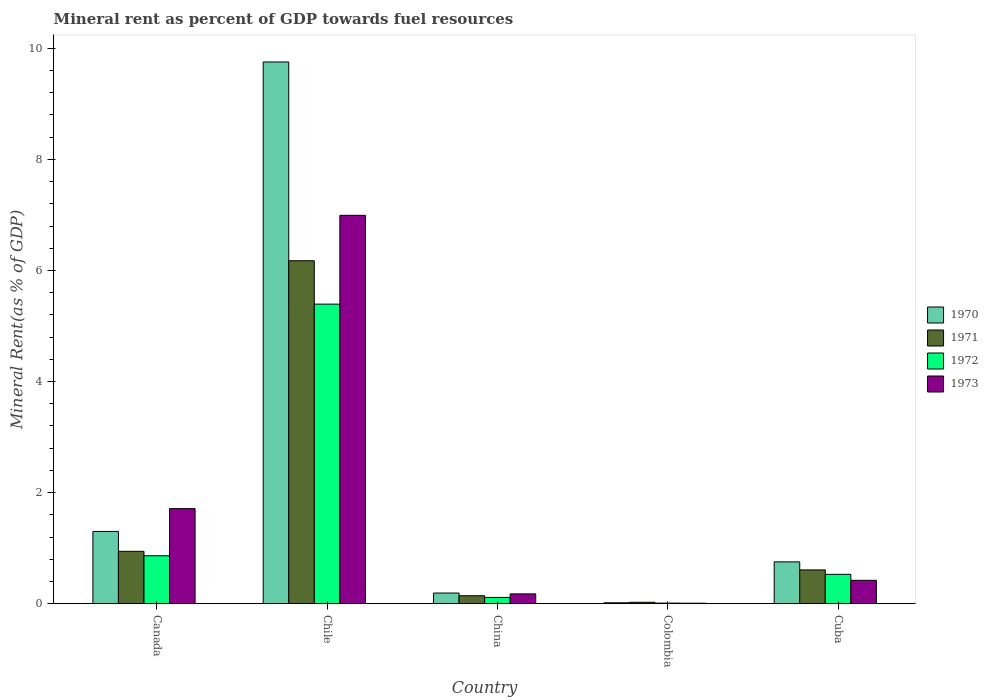How many different coloured bars are there?
Keep it short and to the point. 4. How many groups of bars are there?
Offer a very short reply. 5. Are the number of bars per tick equal to the number of legend labels?
Your response must be concise. Yes. Are the number of bars on each tick of the X-axis equal?
Give a very brief answer. Yes. How many bars are there on the 4th tick from the left?
Keep it short and to the point. 4. What is the label of the 5th group of bars from the left?
Your response must be concise. Cuba. What is the mineral rent in 1973 in China?
Make the answer very short. 0.18. Across all countries, what is the maximum mineral rent in 1973?
Your answer should be compact. 6.99. Across all countries, what is the minimum mineral rent in 1971?
Provide a succinct answer. 0.03. In which country was the mineral rent in 1972 maximum?
Your answer should be compact. Chile. What is the total mineral rent in 1970 in the graph?
Offer a terse response. 12.02. What is the difference between the mineral rent in 1972 in Canada and that in Cuba?
Your answer should be compact. 0.33. What is the difference between the mineral rent in 1970 in Chile and the mineral rent in 1973 in Cuba?
Your response must be concise. 9.33. What is the average mineral rent in 1973 per country?
Keep it short and to the point. 1.86. What is the difference between the mineral rent of/in 1970 and mineral rent of/in 1971 in China?
Offer a terse response. 0.05. In how many countries, is the mineral rent in 1973 greater than 5.6 %?
Provide a succinct answer. 1. What is the ratio of the mineral rent in 1973 in Chile to that in China?
Provide a short and direct response. 39.41. Is the mineral rent in 1971 in Canada less than that in China?
Provide a succinct answer. No. Is the difference between the mineral rent in 1970 in Chile and China greater than the difference between the mineral rent in 1971 in Chile and China?
Provide a succinct answer. Yes. What is the difference between the highest and the second highest mineral rent in 1972?
Provide a succinct answer. 0.33. What is the difference between the highest and the lowest mineral rent in 1971?
Provide a succinct answer. 6.15. In how many countries, is the mineral rent in 1972 greater than the average mineral rent in 1972 taken over all countries?
Offer a terse response. 1. Is the sum of the mineral rent in 1970 in Colombia and Cuba greater than the maximum mineral rent in 1973 across all countries?
Provide a succinct answer. No. Is it the case that in every country, the sum of the mineral rent in 1972 and mineral rent in 1970 is greater than the sum of mineral rent in 1971 and mineral rent in 1973?
Provide a succinct answer. No. What does the 3rd bar from the right in Colombia represents?
Your response must be concise. 1971. Is it the case that in every country, the sum of the mineral rent in 1973 and mineral rent in 1971 is greater than the mineral rent in 1972?
Your response must be concise. Yes. Are all the bars in the graph horizontal?
Give a very brief answer. No. How many countries are there in the graph?
Provide a short and direct response. 5. What is the difference between two consecutive major ticks on the Y-axis?
Provide a short and direct response. 2. Are the values on the major ticks of Y-axis written in scientific E-notation?
Offer a very short reply. No. Does the graph contain any zero values?
Make the answer very short. No. Does the graph contain grids?
Your response must be concise. No. Where does the legend appear in the graph?
Make the answer very short. Center right. How many legend labels are there?
Offer a terse response. 4. What is the title of the graph?
Offer a terse response. Mineral rent as percent of GDP towards fuel resources. Does "1965" appear as one of the legend labels in the graph?
Your answer should be compact. No. What is the label or title of the Y-axis?
Give a very brief answer. Mineral Rent(as % of GDP). What is the Mineral Rent(as % of GDP) in 1970 in Canada?
Ensure brevity in your answer.  1.3. What is the Mineral Rent(as % of GDP) in 1971 in Canada?
Offer a terse response. 0.94. What is the Mineral Rent(as % of GDP) of 1972 in Canada?
Provide a succinct answer. 0.86. What is the Mineral Rent(as % of GDP) in 1973 in Canada?
Your response must be concise. 1.71. What is the Mineral Rent(as % of GDP) of 1970 in Chile?
Provide a short and direct response. 9.75. What is the Mineral Rent(as % of GDP) of 1971 in Chile?
Keep it short and to the point. 6.18. What is the Mineral Rent(as % of GDP) in 1972 in Chile?
Give a very brief answer. 5.39. What is the Mineral Rent(as % of GDP) in 1973 in Chile?
Give a very brief answer. 6.99. What is the Mineral Rent(as % of GDP) in 1970 in China?
Your response must be concise. 0.19. What is the Mineral Rent(as % of GDP) of 1971 in China?
Give a very brief answer. 0.14. What is the Mineral Rent(as % of GDP) in 1972 in China?
Your response must be concise. 0.11. What is the Mineral Rent(as % of GDP) of 1973 in China?
Give a very brief answer. 0.18. What is the Mineral Rent(as % of GDP) of 1970 in Colombia?
Your answer should be compact. 0.02. What is the Mineral Rent(as % of GDP) of 1971 in Colombia?
Offer a terse response. 0.03. What is the Mineral Rent(as % of GDP) of 1972 in Colombia?
Provide a short and direct response. 0.01. What is the Mineral Rent(as % of GDP) of 1973 in Colombia?
Your answer should be compact. 0.01. What is the Mineral Rent(as % of GDP) of 1970 in Cuba?
Provide a short and direct response. 0.75. What is the Mineral Rent(as % of GDP) in 1971 in Cuba?
Ensure brevity in your answer.  0.61. What is the Mineral Rent(as % of GDP) of 1972 in Cuba?
Offer a terse response. 0.53. What is the Mineral Rent(as % of GDP) of 1973 in Cuba?
Make the answer very short. 0.42. Across all countries, what is the maximum Mineral Rent(as % of GDP) of 1970?
Provide a succinct answer. 9.75. Across all countries, what is the maximum Mineral Rent(as % of GDP) of 1971?
Offer a very short reply. 6.18. Across all countries, what is the maximum Mineral Rent(as % of GDP) of 1972?
Ensure brevity in your answer.  5.39. Across all countries, what is the maximum Mineral Rent(as % of GDP) of 1973?
Your answer should be very brief. 6.99. Across all countries, what is the minimum Mineral Rent(as % of GDP) in 1970?
Provide a succinct answer. 0.02. Across all countries, what is the minimum Mineral Rent(as % of GDP) in 1971?
Ensure brevity in your answer.  0.03. Across all countries, what is the minimum Mineral Rent(as % of GDP) of 1972?
Provide a succinct answer. 0.01. Across all countries, what is the minimum Mineral Rent(as % of GDP) in 1973?
Offer a terse response. 0.01. What is the total Mineral Rent(as % of GDP) of 1970 in the graph?
Keep it short and to the point. 12.02. What is the total Mineral Rent(as % of GDP) in 1971 in the graph?
Provide a short and direct response. 7.9. What is the total Mineral Rent(as % of GDP) in 1972 in the graph?
Make the answer very short. 6.91. What is the total Mineral Rent(as % of GDP) in 1973 in the graph?
Your answer should be compact. 9.31. What is the difference between the Mineral Rent(as % of GDP) of 1970 in Canada and that in Chile?
Offer a terse response. -8.45. What is the difference between the Mineral Rent(as % of GDP) in 1971 in Canada and that in Chile?
Your answer should be compact. -5.23. What is the difference between the Mineral Rent(as % of GDP) in 1972 in Canada and that in Chile?
Ensure brevity in your answer.  -4.53. What is the difference between the Mineral Rent(as % of GDP) of 1973 in Canada and that in Chile?
Give a very brief answer. -5.28. What is the difference between the Mineral Rent(as % of GDP) of 1970 in Canada and that in China?
Ensure brevity in your answer.  1.11. What is the difference between the Mineral Rent(as % of GDP) in 1971 in Canada and that in China?
Your response must be concise. 0.8. What is the difference between the Mineral Rent(as % of GDP) in 1972 in Canada and that in China?
Your answer should be very brief. 0.75. What is the difference between the Mineral Rent(as % of GDP) of 1973 in Canada and that in China?
Offer a very short reply. 1.53. What is the difference between the Mineral Rent(as % of GDP) of 1970 in Canada and that in Colombia?
Give a very brief answer. 1.28. What is the difference between the Mineral Rent(as % of GDP) in 1971 in Canada and that in Colombia?
Offer a terse response. 0.92. What is the difference between the Mineral Rent(as % of GDP) of 1972 in Canada and that in Colombia?
Give a very brief answer. 0.85. What is the difference between the Mineral Rent(as % of GDP) of 1973 in Canada and that in Colombia?
Your answer should be compact. 1.7. What is the difference between the Mineral Rent(as % of GDP) in 1970 in Canada and that in Cuba?
Make the answer very short. 0.55. What is the difference between the Mineral Rent(as % of GDP) in 1971 in Canada and that in Cuba?
Keep it short and to the point. 0.33. What is the difference between the Mineral Rent(as % of GDP) in 1972 in Canada and that in Cuba?
Your response must be concise. 0.33. What is the difference between the Mineral Rent(as % of GDP) in 1973 in Canada and that in Cuba?
Your response must be concise. 1.29. What is the difference between the Mineral Rent(as % of GDP) in 1970 in Chile and that in China?
Your response must be concise. 9.56. What is the difference between the Mineral Rent(as % of GDP) of 1971 in Chile and that in China?
Provide a succinct answer. 6.03. What is the difference between the Mineral Rent(as % of GDP) in 1972 in Chile and that in China?
Your answer should be compact. 5.28. What is the difference between the Mineral Rent(as % of GDP) of 1973 in Chile and that in China?
Offer a very short reply. 6.82. What is the difference between the Mineral Rent(as % of GDP) of 1970 in Chile and that in Colombia?
Provide a short and direct response. 9.74. What is the difference between the Mineral Rent(as % of GDP) in 1971 in Chile and that in Colombia?
Your answer should be compact. 6.15. What is the difference between the Mineral Rent(as % of GDP) in 1972 in Chile and that in Colombia?
Provide a short and direct response. 5.38. What is the difference between the Mineral Rent(as % of GDP) in 1973 in Chile and that in Colombia?
Provide a succinct answer. 6.98. What is the difference between the Mineral Rent(as % of GDP) in 1970 in Chile and that in Cuba?
Your answer should be very brief. 9. What is the difference between the Mineral Rent(as % of GDP) of 1971 in Chile and that in Cuba?
Provide a succinct answer. 5.57. What is the difference between the Mineral Rent(as % of GDP) in 1972 in Chile and that in Cuba?
Your response must be concise. 4.86. What is the difference between the Mineral Rent(as % of GDP) of 1973 in Chile and that in Cuba?
Keep it short and to the point. 6.57. What is the difference between the Mineral Rent(as % of GDP) of 1970 in China and that in Colombia?
Your answer should be very brief. 0.18. What is the difference between the Mineral Rent(as % of GDP) of 1971 in China and that in Colombia?
Your response must be concise. 0.12. What is the difference between the Mineral Rent(as % of GDP) in 1972 in China and that in Colombia?
Offer a terse response. 0.1. What is the difference between the Mineral Rent(as % of GDP) in 1973 in China and that in Colombia?
Offer a terse response. 0.17. What is the difference between the Mineral Rent(as % of GDP) of 1970 in China and that in Cuba?
Give a very brief answer. -0.56. What is the difference between the Mineral Rent(as % of GDP) in 1971 in China and that in Cuba?
Your response must be concise. -0.46. What is the difference between the Mineral Rent(as % of GDP) in 1972 in China and that in Cuba?
Give a very brief answer. -0.42. What is the difference between the Mineral Rent(as % of GDP) of 1973 in China and that in Cuba?
Provide a succinct answer. -0.24. What is the difference between the Mineral Rent(as % of GDP) in 1970 in Colombia and that in Cuba?
Keep it short and to the point. -0.74. What is the difference between the Mineral Rent(as % of GDP) in 1971 in Colombia and that in Cuba?
Provide a short and direct response. -0.58. What is the difference between the Mineral Rent(as % of GDP) of 1972 in Colombia and that in Cuba?
Keep it short and to the point. -0.52. What is the difference between the Mineral Rent(as % of GDP) of 1973 in Colombia and that in Cuba?
Give a very brief answer. -0.41. What is the difference between the Mineral Rent(as % of GDP) of 1970 in Canada and the Mineral Rent(as % of GDP) of 1971 in Chile?
Offer a terse response. -4.87. What is the difference between the Mineral Rent(as % of GDP) of 1970 in Canada and the Mineral Rent(as % of GDP) of 1972 in Chile?
Offer a terse response. -4.09. What is the difference between the Mineral Rent(as % of GDP) of 1970 in Canada and the Mineral Rent(as % of GDP) of 1973 in Chile?
Provide a succinct answer. -5.69. What is the difference between the Mineral Rent(as % of GDP) in 1971 in Canada and the Mineral Rent(as % of GDP) in 1972 in Chile?
Your answer should be very brief. -4.45. What is the difference between the Mineral Rent(as % of GDP) of 1971 in Canada and the Mineral Rent(as % of GDP) of 1973 in Chile?
Give a very brief answer. -6.05. What is the difference between the Mineral Rent(as % of GDP) in 1972 in Canada and the Mineral Rent(as % of GDP) in 1973 in Chile?
Offer a terse response. -6.13. What is the difference between the Mineral Rent(as % of GDP) of 1970 in Canada and the Mineral Rent(as % of GDP) of 1971 in China?
Provide a short and direct response. 1.16. What is the difference between the Mineral Rent(as % of GDP) of 1970 in Canada and the Mineral Rent(as % of GDP) of 1972 in China?
Provide a short and direct response. 1.19. What is the difference between the Mineral Rent(as % of GDP) of 1970 in Canada and the Mineral Rent(as % of GDP) of 1973 in China?
Offer a very short reply. 1.12. What is the difference between the Mineral Rent(as % of GDP) in 1971 in Canada and the Mineral Rent(as % of GDP) in 1972 in China?
Give a very brief answer. 0.83. What is the difference between the Mineral Rent(as % of GDP) in 1971 in Canada and the Mineral Rent(as % of GDP) in 1973 in China?
Ensure brevity in your answer.  0.77. What is the difference between the Mineral Rent(as % of GDP) in 1972 in Canada and the Mineral Rent(as % of GDP) in 1973 in China?
Provide a succinct answer. 0.69. What is the difference between the Mineral Rent(as % of GDP) of 1970 in Canada and the Mineral Rent(as % of GDP) of 1971 in Colombia?
Give a very brief answer. 1.28. What is the difference between the Mineral Rent(as % of GDP) in 1970 in Canada and the Mineral Rent(as % of GDP) in 1972 in Colombia?
Make the answer very short. 1.29. What is the difference between the Mineral Rent(as % of GDP) of 1970 in Canada and the Mineral Rent(as % of GDP) of 1973 in Colombia?
Keep it short and to the point. 1.29. What is the difference between the Mineral Rent(as % of GDP) of 1971 in Canada and the Mineral Rent(as % of GDP) of 1972 in Colombia?
Provide a succinct answer. 0.93. What is the difference between the Mineral Rent(as % of GDP) of 1971 in Canada and the Mineral Rent(as % of GDP) of 1973 in Colombia?
Provide a short and direct response. 0.93. What is the difference between the Mineral Rent(as % of GDP) in 1972 in Canada and the Mineral Rent(as % of GDP) in 1973 in Colombia?
Provide a succinct answer. 0.85. What is the difference between the Mineral Rent(as % of GDP) of 1970 in Canada and the Mineral Rent(as % of GDP) of 1971 in Cuba?
Make the answer very short. 0.69. What is the difference between the Mineral Rent(as % of GDP) of 1970 in Canada and the Mineral Rent(as % of GDP) of 1972 in Cuba?
Ensure brevity in your answer.  0.77. What is the difference between the Mineral Rent(as % of GDP) of 1970 in Canada and the Mineral Rent(as % of GDP) of 1973 in Cuba?
Your response must be concise. 0.88. What is the difference between the Mineral Rent(as % of GDP) in 1971 in Canada and the Mineral Rent(as % of GDP) in 1972 in Cuba?
Your answer should be compact. 0.41. What is the difference between the Mineral Rent(as % of GDP) of 1971 in Canada and the Mineral Rent(as % of GDP) of 1973 in Cuba?
Your answer should be very brief. 0.52. What is the difference between the Mineral Rent(as % of GDP) in 1972 in Canada and the Mineral Rent(as % of GDP) in 1973 in Cuba?
Your answer should be very brief. 0.44. What is the difference between the Mineral Rent(as % of GDP) in 1970 in Chile and the Mineral Rent(as % of GDP) in 1971 in China?
Provide a succinct answer. 9.61. What is the difference between the Mineral Rent(as % of GDP) of 1970 in Chile and the Mineral Rent(as % of GDP) of 1972 in China?
Your answer should be very brief. 9.64. What is the difference between the Mineral Rent(as % of GDP) of 1970 in Chile and the Mineral Rent(as % of GDP) of 1973 in China?
Make the answer very short. 9.58. What is the difference between the Mineral Rent(as % of GDP) in 1971 in Chile and the Mineral Rent(as % of GDP) in 1972 in China?
Give a very brief answer. 6.06. What is the difference between the Mineral Rent(as % of GDP) of 1971 in Chile and the Mineral Rent(as % of GDP) of 1973 in China?
Offer a terse response. 6. What is the difference between the Mineral Rent(as % of GDP) of 1972 in Chile and the Mineral Rent(as % of GDP) of 1973 in China?
Your answer should be very brief. 5.22. What is the difference between the Mineral Rent(as % of GDP) of 1970 in Chile and the Mineral Rent(as % of GDP) of 1971 in Colombia?
Provide a succinct answer. 9.73. What is the difference between the Mineral Rent(as % of GDP) in 1970 in Chile and the Mineral Rent(as % of GDP) in 1972 in Colombia?
Provide a succinct answer. 9.74. What is the difference between the Mineral Rent(as % of GDP) in 1970 in Chile and the Mineral Rent(as % of GDP) in 1973 in Colombia?
Your answer should be very brief. 9.74. What is the difference between the Mineral Rent(as % of GDP) in 1971 in Chile and the Mineral Rent(as % of GDP) in 1972 in Colombia?
Your answer should be very brief. 6.16. What is the difference between the Mineral Rent(as % of GDP) of 1971 in Chile and the Mineral Rent(as % of GDP) of 1973 in Colombia?
Your response must be concise. 6.17. What is the difference between the Mineral Rent(as % of GDP) in 1972 in Chile and the Mineral Rent(as % of GDP) in 1973 in Colombia?
Your answer should be very brief. 5.38. What is the difference between the Mineral Rent(as % of GDP) in 1970 in Chile and the Mineral Rent(as % of GDP) in 1971 in Cuba?
Give a very brief answer. 9.15. What is the difference between the Mineral Rent(as % of GDP) of 1970 in Chile and the Mineral Rent(as % of GDP) of 1972 in Cuba?
Give a very brief answer. 9.22. What is the difference between the Mineral Rent(as % of GDP) of 1970 in Chile and the Mineral Rent(as % of GDP) of 1973 in Cuba?
Offer a terse response. 9.33. What is the difference between the Mineral Rent(as % of GDP) in 1971 in Chile and the Mineral Rent(as % of GDP) in 1972 in Cuba?
Ensure brevity in your answer.  5.65. What is the difference between the Mineral Rent(as % of GDP) of 1971 in Chile and the Mineral Rent(as % of GDP) of 1973 in Cuba?
Ensure brevity in your answer.  5.75. What is the difference between the Mineral Rent(as % of GDP) in 1972 in Chile and the Mineral Rent(as % of GDP) in 1973 in Cuba?
Keep it short and to the point. 4.97. What is the difference between the Mineral Rent(as % of GDP) in 1970 in China and the Mineral Rent(as % of GDP) in 1971 in Colombia?
Give a very brief answer. 0.17. What is the difference between the Mineral Rent(as % of GDP) in 1970 in China and the Mineral Rent(as % of GDP) in 1972 in Colombia?
Your answer should be compact. 0.18. What is the difference between the Mineral Rent(as % of GDP) of 1970 in China and the Mineral Rent(as % of GDP) of 1973 in Colombia?
Your answer should be compact. 0.18. What is the difference between the Mineral Rent(as % of GDP) in 1971 in China and the Mineral Rent(as % of GDP) in 1972 in Colombia?
Provide a short and direct response. 0.13. What is the difference between the Mineral Rent(as % of GDP) of 1971 in China and the Mineral Rent(as % of GDP) of 1973 in Colombia?
Your answer should be compact. 0.13. What is the difference between the Mineral Rent(as % of GDP) of 1972 in China and the Mineral Rent(as % of GDP) of 1973 in Colombia?
Keep it short and to the point. 0.1. What is the difference between the Mineral Rent(as % of GDP) in 1970 in China and the Mineral Rent(as % of GDP) in 1971 in Cuba?
Provide a succinct answer. -0.42. What is the difference between the Mineral Rent(as % of GDP) in 1970 in China and the Mineral Rent(as % of GDP) in 1972 in Cuba?
Your answer should be compact. -0.34. What is the difference between the Mineral Rent(as % of GDP) in 1970 in China and the Mineral Rent(as % of GDP) in 1973 in Cuba?
Ensure brevity in your answer.  -0.23. What is the difference between the Mineral Rent(as % of GDP) of 1971 in China and the Mineral Rent(as % of GDP) of 1972 in Cuba?
Make the answer very short. -0.39. What is the difference between the Mineral Rent(as % of GDP) of 1971 in China and the Mineral Rent(as % of GDP) of 1973 in Cuba?
Keep it short and to the point. -0.28. What is the difference between the Mineral Rent(as % of GDP) in 1972 in China and the Mineral Rent(as % of GDP) in 1973 in Cuba?
Provide a succinct answer. -0.31. What is the difference between the Mineral Rent(as % of GDP) in 1970 in Colombia and the Mineral Rent(as % of GDP) in 1971 in Cuba?
Ensure brevity in your answer.  -0.59. What is the difference between the Mineral Rent(as % of GDP) of 1970 in Colombia and the Mineral Rent(as % of GDP) of 1972 in Cuba?
Keep it short and to the point. -0.51. What is the difference between the Mineral Rent(as % of GDP) of 1970 in Colombia and the Mineral Rent(as % of GDP) of 1973 in Cuba?
Your response must be concise. -0.4. What is the difference between the Mineral Rent(as % of GDP) of 1971 in Colombia and the Mineral Rent(as % of GDP) of 1972 in Cuba?
Make the answer very short. -0.5. What is the difference between the Mineral Rent(as % of GDP) in 1971 in Colombia and the Mineral Rent(as % of GDP) in 1973 in Cuba?
Give a very brief answer. -0.4. What is the difference between the Mineral Rent(as % of GDP) in 1972 in Colombia and the Mineral Rent(as % of GDP) in 1973 in Cuba?
Keep it short and to the point. -0.41. What is the average Mineral Rent(as % of GDP) of 1970 per country?
Provide a short and direct response. 2.4. What is the average Mineral Rent(as % of GDP) in 1971 per country?
Give a very brief answer. 1.58. What is the average Mineral Rent(as % of GDP) of 1972 per country?
Offer a terse response. 1.38. What is the average Mineral Rent(as % of GDP) of 1973 per country?
Your answer should be very brief. 1.86. What is the difference between the Mineral Rent(as % of GDP) in 1970 and Mineral Rent(as % of GDP) in 1971 in Canada?
Give a very brief answer. 0.36. What is the difference between the Mineral Rent(as % of GDP) in 1970 and Mineral Rent(as % of GDP) in 1972 in Canada?
Offer a terse response. 0.44. What is the difference between the Mineral Rent(as % of GDP) of 1970 and Mineral Rent(as % of GDP) of 1973 in Canada?
Ensure brevity in your answer.  -0.41. What is the difference between the Mineral Rent(as % of GDP) of 1971 and Mineral Rent(as % of GDP) of 1972 in Canada?
Make the answer very short. 0.08. What is the difference between the Mineral Rent(as % of GDP) in 1971 and Mineral Rent(as % of GDP) in 1973 in Canada?
Offer a terse response. -0.77. What is the difference between the Mineral Rent(as % of GDP) of 1972 and Mineral Rent(as % of GDP) of 1973 in Canada?
Make the answer very short. -0.85. What is the difference between the Mineral Rent(as % of GDP) in 1970 and Mineral Rent(as % of GDP) in 1971 in Chile?
Provide a short and direct response. 3.58. What is the difference between the Mineral Rent(as % of GDP) in 1970 and Mineral Rent(as % of GDP) in 1972 in Chile?
Your answer should be very brief. 4.36. What is the difference between the Mineral Rent(as % of GDP) of 1970 and Mineral Rent(as % of GDP) of 1973 in Chile?
Provide a short and direct response. 2.76. What is the difference between the Mineral Rent(as % of GDP) in 1971 and Mineral Rent(as % of GDP) in 1972 in Chile?
Keep it short and to the point. 0.78. What is the difference between the Mineral Rent(as % of GDP) of 1971 and Mineral Rent(as % of GDP) of 1973 in Chile?
Keep it short and to the point. -0.82. What is the difference between the Mineral Rent(as % of GDP) of 1972 and Mineral Rent(as % of GDP) of 1973 in Chile?
Your answer should be compact. -1.6. What is the difference between the Mineral Rent(as % of GDP) in 1970 and Mineral Rent(as % of GDP) in 1971 in China?
Provide a succinct answer. 0.05. What is the difference between the Mineral Rent(as % of GDP) of 1970 and Mineral Rent(as % of GDP) of 1972 in China?
Provide a succinct answer. 0.08. What is the difference between the Mineral Rent(as % of GDP) of 1970 and Mineral Rent(as % of GDP) of 1973 in China?
Offer a terse response. 0.02. What is the difference between the Mineral Rent(as % of GDP) in 1971 and Mineral Rent(as % of GDP) in 1972 in China?
Provide a short and direct response. 0.03. What is the difference between the Mineral Rent(as % of GDP) of 1971 and Mineral Rent(as % of GDP) of 1973 in China?
Give a very brief answer. -0.03. What is the difference between the Mineral Rent(as % of GDP) of 1972 and Mineral Rent(as % of GDP) of 1973 in China?
Your answer should be very brief. -0.06. What is the difference between the Mineral Rent(as % of GDP) in 1970 and Mineral Rent(as % of GDP) in 1971 in Colombia?
Make the answer very short. -0.01. What is the difference between the Mineral Rent(as % of GDP) in 1970 and Mineral Rent(as % of GDP) in 1972 in Colombia?
Provide a succinct answer. 0.01. What is the difference between the Mineral Rent(as % of GDP) of 1970 and Mineral Rent(as % of GDP) of 1973 in Colombia?
Your answer should be compact. 0.01. What is the difference between the Mineral Rent(as % of GDP) of 1971 and Mineral Rent(as % of GDP) of 1972 in Colombia?
Keep it short and to the point. 0.01. What is the difference between the Mineral Rent(as % of GDP) in 1971 and Mineral Rent(as % of GDP) in 1973 in Colombia?
Offer a terse response. 0.02. What is the difference between the Mineral Rent(as % of GDP) in 1972 and Mineral Rent(as % of GDP) in 1973 in Colombia?
Provide a short and direct response. 0. What is the difference between the Mineral Rent(as % of GDP) of 1970 and Mineral Rent(as % of GDP) of 1971 in Cuba?
Provide a succinct answer. 0.14. What is the difference between the Mineral Rent(as % of GDP) in 1970 and Mineral Rent(as % of GDP) in 1972 in Cuba?
Offer a terse response. 0.22. What is the difference between the Mineral Rent(as % of GDP) in 1970 and Mineral Rent(as % of GDP) in 1973 in Cuba?
Keep it short and to the point. 0.33. What is the difference between the Mineral Rent(as % of GDP) in 1971 and Mineral Rent(as % of GDP) in 1972 in Cuba?
Keep it short and to the point. 0.08. What is the difference between the Mineral Rent(as % of GDP) in 1971 and Mineral Rent(as % of GDP) in 1973 in Cuba?
Provide a short and direct response. 0.19. What is the difference between the Mineral Rent(as % of GDP) in 1972 and Mineral Rent(as % of GDP) in 1973 in Cuba?
Keep it short and to the point. 0.11. What is the ratio of the Mineral Rent(as % of GDP) in 1970 in Canada to that in Chile?
Make the answer very short. 0.13. What is the ratio of the Mineral Rent(as % of GDP) of 1971 in Canada to that in Chile?
Your response must be concise. 0.15. What is the ratio of the Mineral Rent(as % of GDP) in 1972 in Canada to that in Chile?
Your answer should be compact. 0.16. What is the ratio of the Mineral Rent(as % of GDP) in 1973 in Canada to that in Chile?
Provide a short and direct response. 0.24. What is the ratio of the Mineral Rent(as % of GDP) in 1970 in Canada to that in China?
Provide a succinct answer. 6.76. What is the ratio of the Mineral Rent(as % of GDP) of 1971 in Canada to that in China?
Provide a short and direct response. 6.54. What is the ratio of the Mineral Rent(as % of GDP) in 1972 in Canada to that in China?
Keep it short and to the point. 7.61. What is the ratio of the Mineral Rent(as % of GDP) in 1973 in Canada to that in China?
Offer a very short reply. 9.65. What is the ratio of the Mineral Rent(as % of GDP) of 1970 in Canada to that in Colombia?
Offer a very short reply. 75.77. What is the ratio of the Mineral Rent(as % of GDP) of 1971 in Canada to that in Colombia?
Ensure brevity in your answer.  36.15. What is the ratio of the Mineral Rent(as % of GDP) of 1972 in Canada to that in Colombia?
Offer a terse response. 77.46. What is the ratio of the Mineral Rent(as % of GDP) of 1973 in Canada to that in Colombia?
Your response must be concise. 183.14. What is the ratio of the Mineral Rent(as % of GDP) of 1970 in Canada to that in Cuba?
Offer a very short reply. 1.73. What is the ratio of the Mineral Rent(as % of GDP) in 1971 in Canada to that in Cuba?
Provide a succinct answer. 1.55. What is the ratio of the Mineral Rent(as % of GDP) in 1972 in Canada to that in Cuba?
Offer a very short reply. 1.63. What is the ratio of the Mineral Rent(as % of GDP) in 1973 in Canada to that in Cuba?
Give a very brief answer. 4.06. What is the ratio of the Mineral Rent(as % of GDP) in 1970 in Chile to that in China?
Your answer should be compact. 50.65. What is the ratio of the Mineral Rent(as % of GDP) in 1971 in Chile to that in China?
Keep it short and to the point. 42.82. What is the ratio of the Mineral Rent(as % of GDP) of 1972 in Chile to that in China?
Ensure brevity in your answer.  47.55. What is the ratio of the Mineral Rent(as % of GDP) in 1973 in Chile to that in China?
Offer a terse response. 39.41. What is the ratio of the Mineral Rent(as % of GDP) in 1970 in Chile to that in Colombia?
Your answer should be compact. 567.75. What is the ratio of the Mineral Rent(as % of GDP) in 1971 in Chile to that in Colombia?
Your answer should be very brief. 236.61. What is the ratio of the Mineral Rent(as % of GDP) of 1972 in Chile to that in Colombia?
Your answer should be very brief. 483.8. What is the ratio of the Mineral Rent(as % of GDP) of 1973 in Chile to that in Colombia?
Your answer should be compact. 747.96. What is the ratio of the Mineral Rent(as % of GDP) of 1970 in Chile to that in Cuba?
Provide a succinct answer. 12.94. What is the ratio of the Mineral Rent(as % of GDP) in 1971 in Chile to that in Cuba?
Your answer should be very brief. 10.14. What is the ratio of the Mineral Rent(as % of GDP) in 1972 in Chile to that in Cuba?
Make the answer very short. 10.19. What is the ratio of the Mineral Rent(as % of GDP) of 1973 in Chile to that in Cuba?
Ensure brevity in your answer.  16.59. What is the ratio of the Mineral Rent(as % of GDP) in 1970 in China to that in Colombia?
Provide a succinct answer. 11.21. What is the ratio of the Mineral Rent(as % of GDP) in 1971 in China to that in Colombia?
Keep it short and to the point. 5.53. What is the ratio of the Mineral Rent(as % of GDP) in 1972 in China to that in Colombia?
Offer a terse response. 10.17. What is the ratio of the Mineral Rent(as % of GDP) in 1973 in China to that in Colombia?
Keep it short and to the point. 18.98. What is the ratio of the Mineral Rent(as % of GDP) of 1970 in China to that in Cuba?
Offer a terse response. 0.26. What is the ratio of the Mineral Rent(as % of GDP) of 1971 in China to that in Cuba?
Offer a terse response. 0.24. What is the ratio of the Mineral Rent(as % of GDP) of 1972 in China to that in Cuba?
Give a very brief answer. 0.21. What is the ratio of the Mineral Rent(as % of GDP) of 1973 in China to that in Cuba?
Your answer should be very brief. 0.42. What is the ratio of the Mineral Rent(as % of GDP) in 1970 in Colombia to that in Cuba?
Give a very brief answer. 0.02. What is the ratio of the Mineral Rent(as % of GDP) of 1971 in Colombia to that in Cuba?
Ensure brevity in your answer.  0.04. What is the ratio of the Mineral Rent(as % of GDP) of 1972 in Colombia to that in Cuba?
Offer a very short reply. 0.02. What is the ratio of the Mineral Rent(as % of GDP) of 1973 in Colombia to that in Cuba?
Offer a very short reply. 0.02. What is the difference between the highest and the second highest Mineral Rent(as % of GDP) of 1970?
Give a very brief answer. 8.45. What is the difference between the highest and the second highest Mineral Rent(as % of GDP) of 1971?
Your response must be concise. 5.23. What is the difference between the highest and the second highest Mineral Rent(as % of GDP) in 1972?
Offer a terse response. 4.53. What is the difference between the highest and the second highest Mineral Rent(as % of GDP) of 1973?
Give a very brief answer. 5.28. What is the difference between the highest and the lowest Mineral Rent(as % of GDP) of 1970?
Make the answer very short. 9.74. What is the difference between the highest and the lowest Mineral Rent(as % of GDP) of 1971?
Ensure brevity in your answer.  6.15. What is the difference between the highest and the lowest Mineral Rent(as % of GDP) in 1972?
Your answer should be compact. 5.38. What is the difference between the highest and the lowest Mineral Rent(as % of GDP) of 1973?
Your response must be concise. 6.98. 